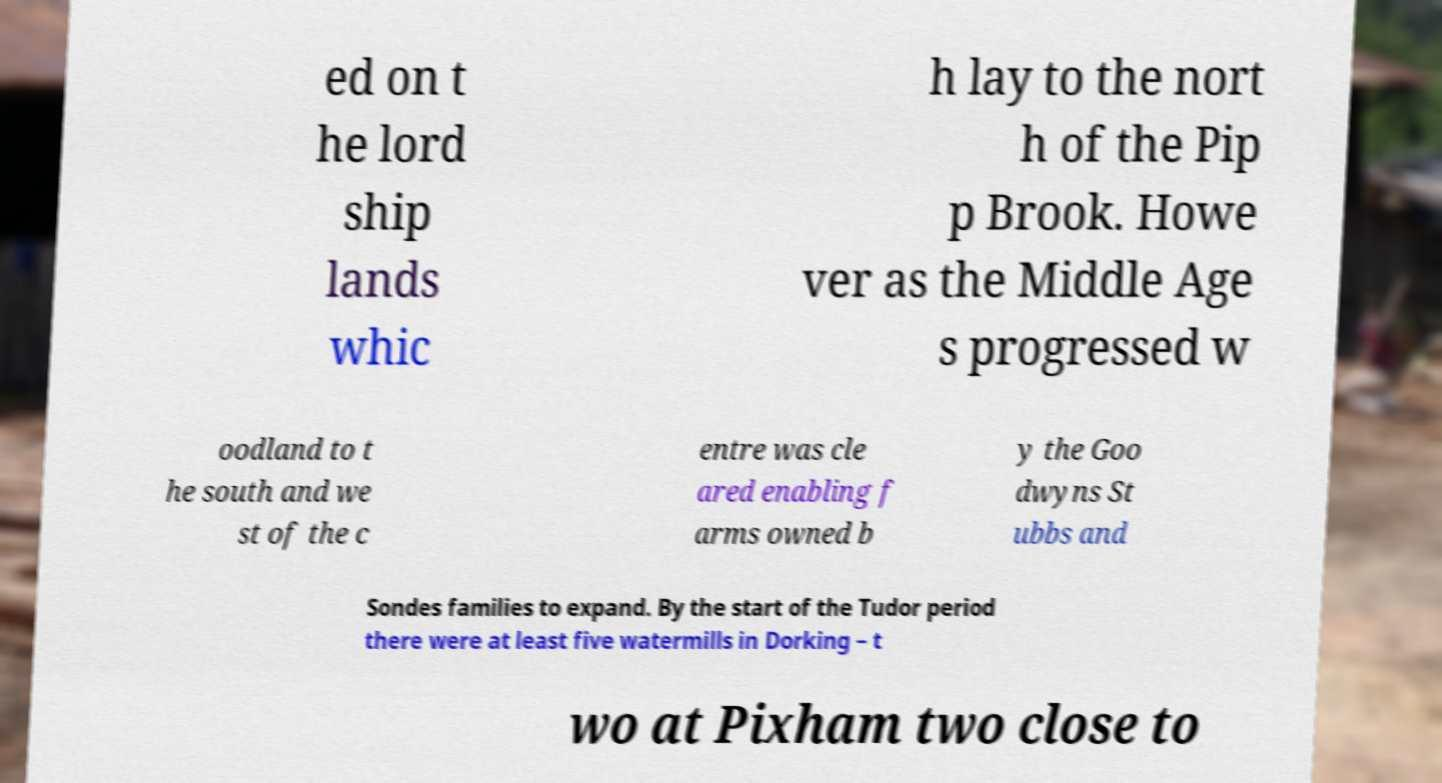I need the written content from this picture converted into text. Can you do that? ed on t he lord ship lands whic h lay to the nort h of the Pip p Brook. Howe ver as the Middle Age s progressed w oodland to t he south and we st of the c entre was cle ared enabling f arms owned b y the Goo dwyns St ubbs and Sondes families to expand. By the start of the Tudor period there were at least five watermills in Dorking – t wo at Pixham two close to 